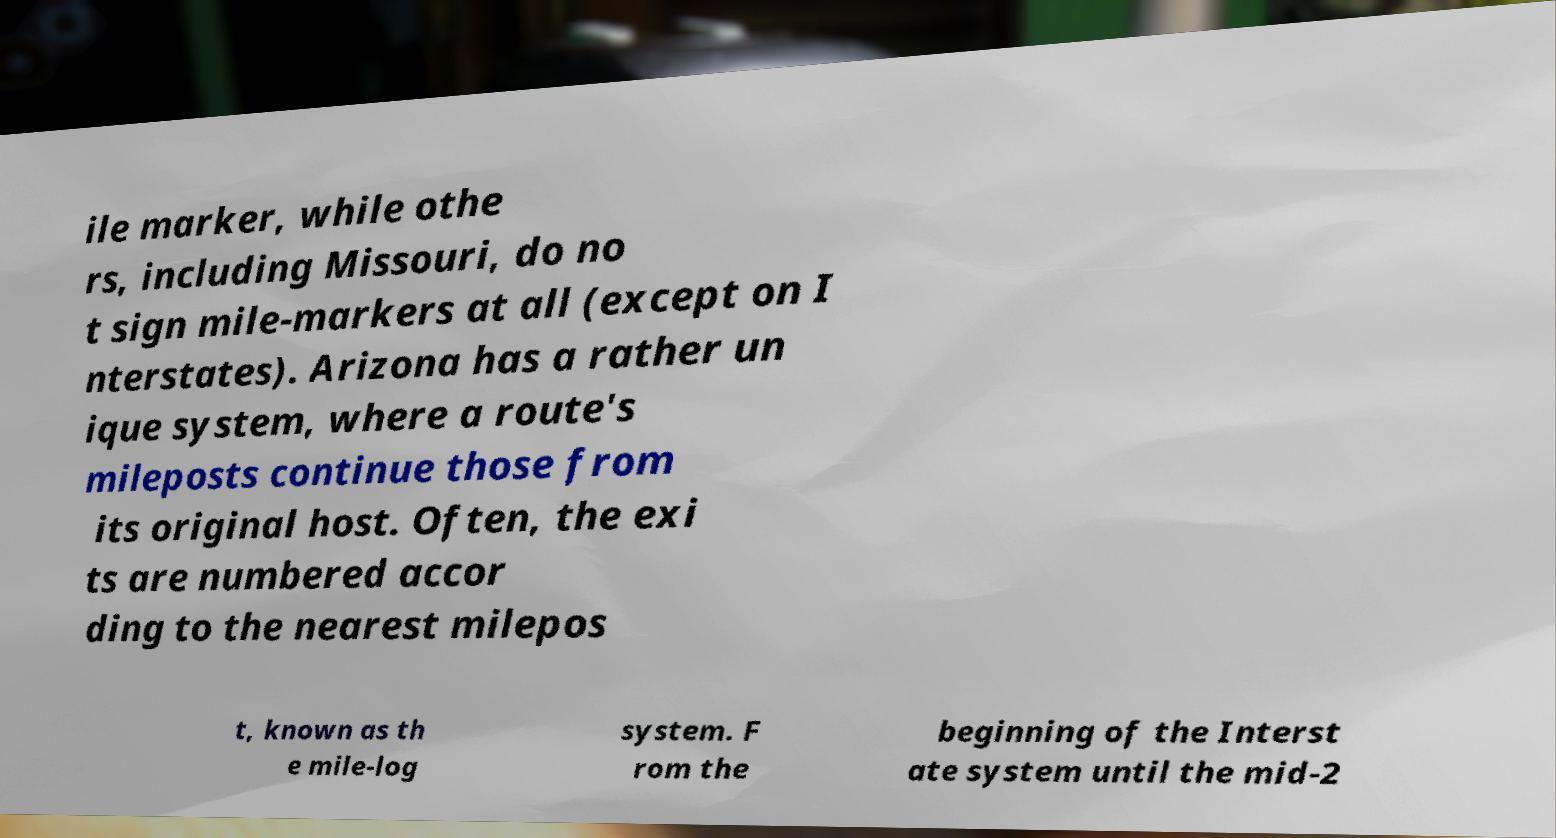For documentation purposes, I need the text within this image transcribed. Could you provide that? ile marker, while othe rs, including Missouri, do no t sign mile-markers at all (except on I nterstates). Arizona has a rather un ique system, where a route's mileposts continue those from its original host. Often, the exi ts are numbered accor ding to the nearest milepos t, known as th e mile-log system. F rom the beginning of the Interst ate system until the mid-2 